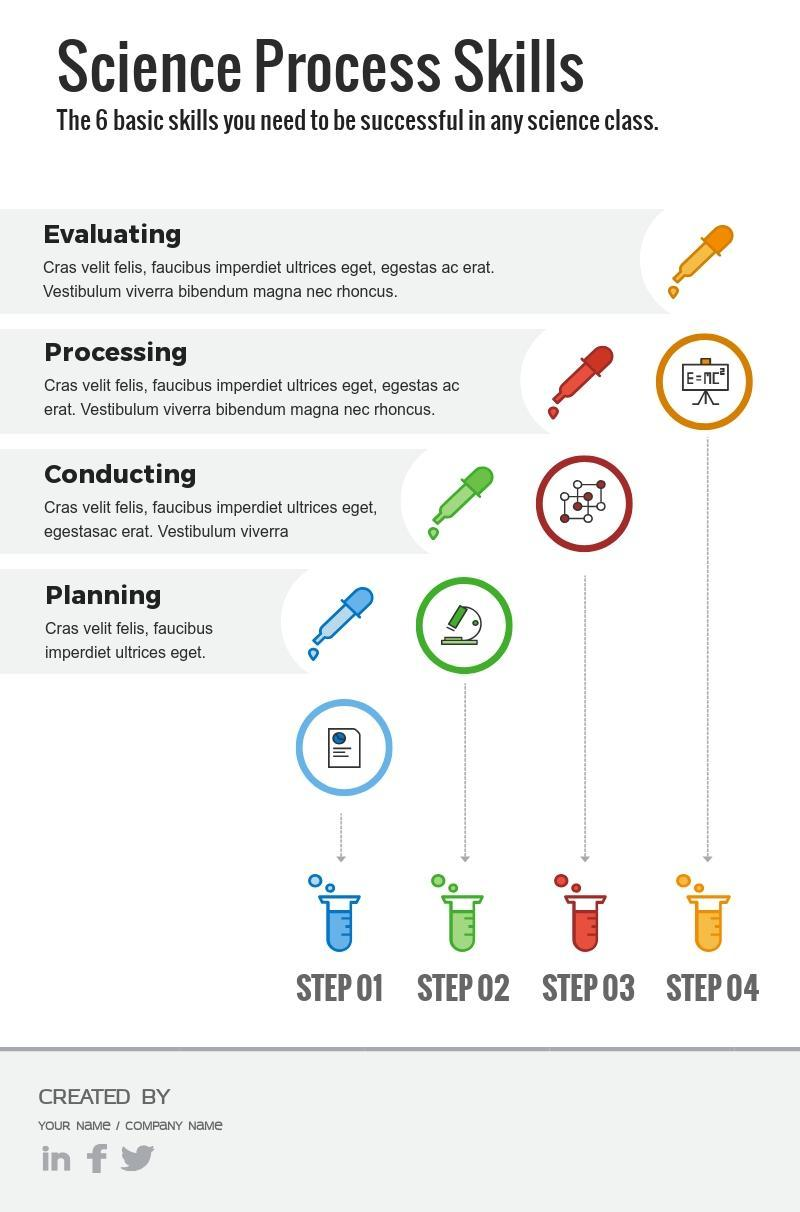Which color used to represent "Processing"-blue, green, red, orange?
Answer the question with a short phrase. red Which color used to represent "Evaluating"-blue, green, orange, red? orange 